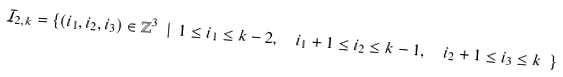<formula> <loc_0><loc_0><loc_500><loc_500>\mathcal { I } _ { 2 , k } = \{ ( i _ { 1 } , i _ { 2 } , i _ { 3 } ) \in \mathbb { Z } ^ { 3 } \ | \ 1 \leq i _ { 1 } \leq k - 2 , \ \ i _ { 1 } + 1 \leq i _ { 2 } \leq k - 1 , \ \ i _ { 2 } + 1 \leq i _ { 3 } \leq k \ \}</formula> 